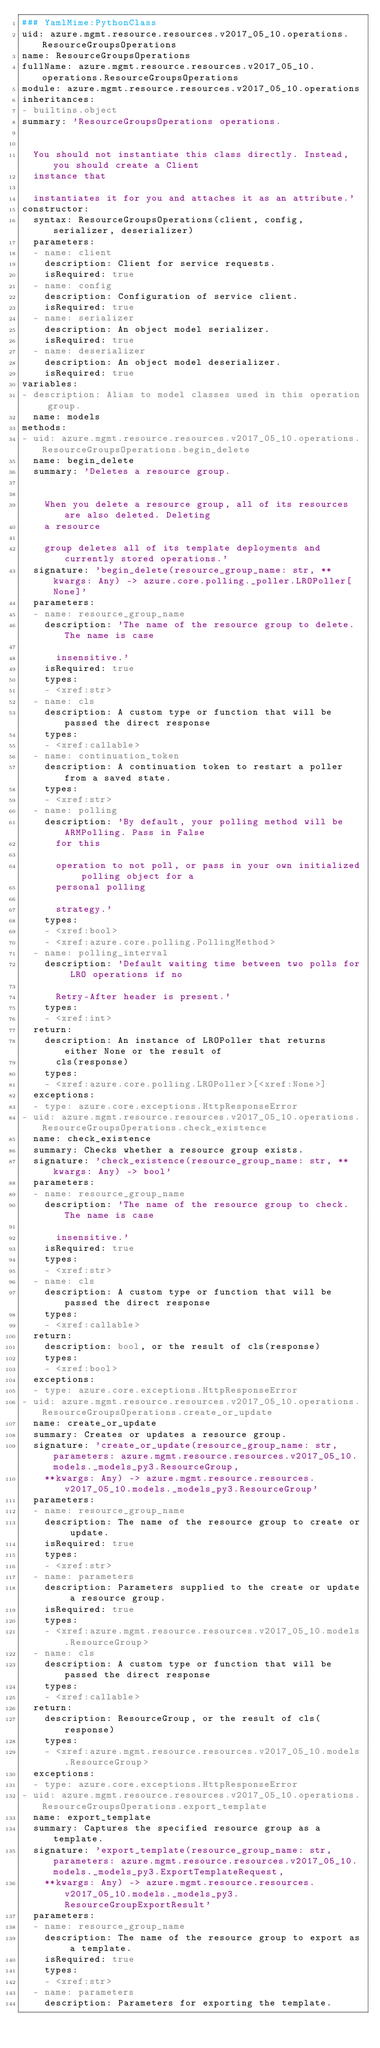Convert code to text. <code><loc_0><loc_0><loc_500><loc_500><_YAML_>### YamlMime:PythonClass
uid: azure.mgmt.resource.resources.v2017_05_10.operations.ResourceGroupsOperations
name: ResourceGroupsOperations
fullName: azure.mgmt.resource.resources.v2017_05_10.operations.ResourceGroupsOperations
module: azure.mgmt.resource.resources.v2017_05_10.operations
inheritances:
- builtins.object
summary: 'ResourceGroupsOperations operations.


  You should not instantiate this class directly. Instead, you should create a Client
  instance that

  instantiates it for you and attaches it as an attribute.'
constructor:
  syntax: ResourceGroupsOperations(client, config, serializer, deserializer)
  parameters:
  - name: client
    description: Client for service requests.
    isRequired: true
  - name: config
    description: Configuration of service client.
    isRequired: true
  - name: serializer
    description: An object model serializer.
    isRequired: true
  - name: deserializer
    description: An object model deserializer.
    isRequired: true
variables:
- description: Alias to model classes used in this operation group.
  name: models
methods:
- uid: azure.mgmt.resource.resources.v2017_05_10.operations.ResourceGroupsOperations.begin_delete
  name: begin_delete
  summary: 'Deletes a resource group.


    When you delete a resource group, all of its resources are also deleted. Deleting
    a resource

    group deletes all of its template deployments and currently stored operations.'
  signature: 'begin_delete(resource_group_name: str, **kwargs: Any) -> azure.core.polling._poller.LROPoller[None]'
  parameters:
  - name: resource_group_name
    description: 'The name of the resource group to delete. The name is case

      insensitive.'
    isRequired: true
    types:
    - <xref:str>
  - name: cls
    description: A custom type or function that will be passed the direct response
    types:
    - <xref:callable>
  - name: continuation_token
    description: A continuation token to restart a poller from a saved state.
    types:
    - <xref:str>
  - name: polling
    description: 'By default, your polling method will be ARMPolling. Pass in False
      for this

      operation to not poll, or pass in your own initialized polling object for a
      personal polling

      strategy.'
    types:
    - <xref:bool>
    - <xref:azure.core.polling.PollingMethod>
  - name: polling_interval
    description: 'Default waiting time between two polls for LRO operations if no

      Retry-After header is present.'
    types:
    - <xref:int>
  return:
    description: An instance of LROPoller that returns either None or the result of
      cls(response)
    types:
    - <xref:azure.core.polling.LROPoller>[<xref:None>]
  exceptions:
  - type: azure.core.exceptions.HttpResponseError
- uid: azure.mgmt.resource.resources.v2017_05_10.operations.ResourceGroupsOperations.check_existence
  name: check_existence
  summary: Checks whether a resource group exists.
  signature: 'check_existence(resource_group_name: str, **kwargs: Any) -> bool'
  parameters:
  - name: resource_group_name
    description: 'The name of the resource group to check. The name is case

      insensitive.'
    isRequired: true
    types:
    - <xref:str>
  - name: cls
    description: A custom type or function that will be passed the direct response
    types:
    - <xref:callable>
  return:
    description: bool, or the result of cls(response)
    types:
    - <xref:bool>
  exceptions:
  - type: azure.core.exceptions.HttpResponseError
- uid: azure.mgmt.resource.resources.v2017_05_10.operations.ResourceGroupsOperations.create_or_update
  name: create_or_update
  summary: Creates or updates a resource group.
  signature: 'create_or_update(resource_group_name: str, parameters: azure.mgmt.resource.resources.v2017_05_10.models._models_py3.ResourceGroup,
    **kwargs: Any) -> azure.mgmt.resource.resources.v2017_05_10.models._models_py3.ResourceGroup'
  parameters:
  - name: resource_group_name
    description: The name of the resource group to create or update.
    isRequired: true
    types:
    - <xref:str>
  - name: parameters
    description: Parameters supplied to the create or update a resource group.
    isRequired: true
    types:
    - <xref:azure.mgmt.resource.resources.v2017_05_10.models.ResourceGroup>
  - name: cls
    description: A custom type or function that will be passed the direct response
    types:
    - <xref:callable>
  return:
    description: ResourceGroup, or the result of cls(response)
    types:
    - <xref:azure.mgmt.resource.resources.v2017_05_10.models.ResourceGroup>
  exceptions:
  - type: azure.core.exceptions.HttpResponseError
- uid: azure.mgmt.resource.resources.v2017_05_10.operations.ResourceGroupsOperations.export_template
  name: export_template
  summary: Captures the specified resource group as a template.
  signature: 'export_template(resource_group_name: str, parameters: azure.mgmt.resource.resources.v2017_05_10.models._models_py3.ExportTemplateRequest,
    **kwargs: Any) -> azure.mgmt.resource.resources.v2017_05_10.models._models_py3.ResourceGroupExportResult'
  parameters:
  - name: resource_group_name
    description: The name of the resource group to export as a template.
    isRequired: true
    types:
    - <xref:str>
  - name: parameters
    description: Parameters for exporting the template.</code> 